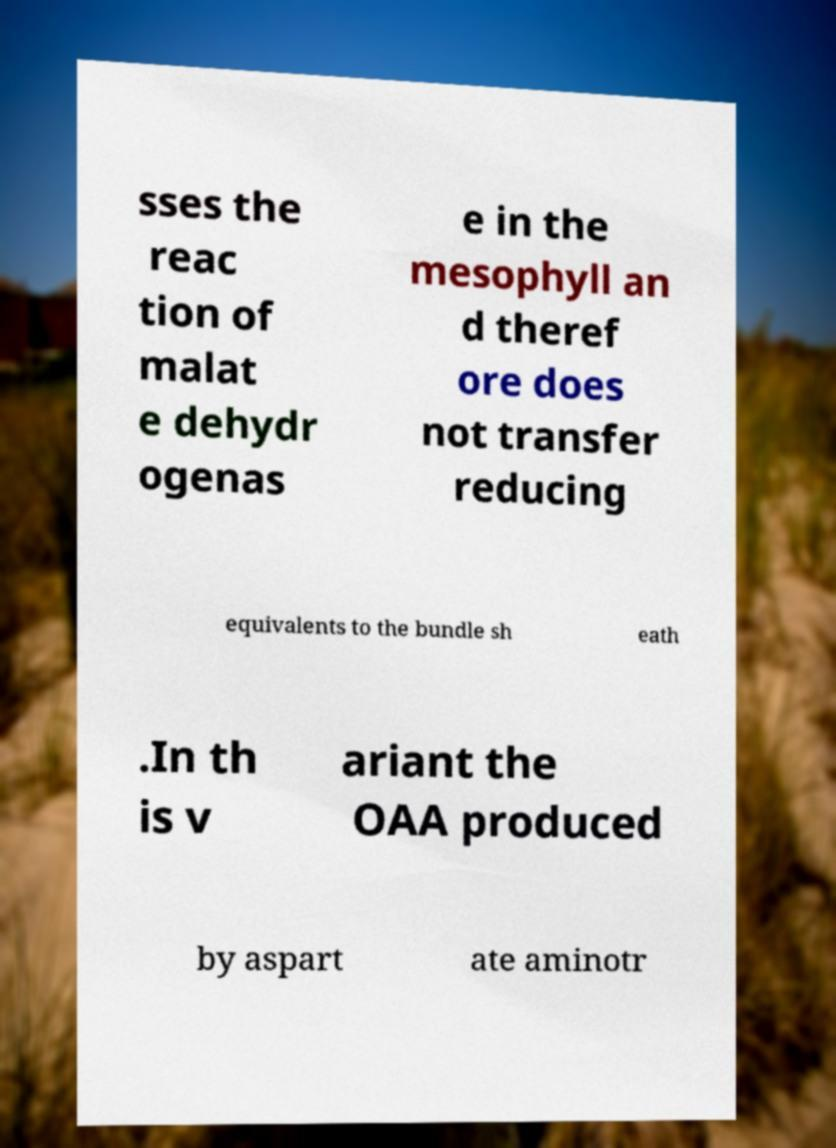Could you assist in decoding the text presented in this image and type it out clearly? sses the reac tion of malat e dehydr ogenas e in the mesophyll an d theref ore does not transfer reducing equivalents to the bundle sh eath .In th is v ariant the OAA produced by aspart ate aminotr 